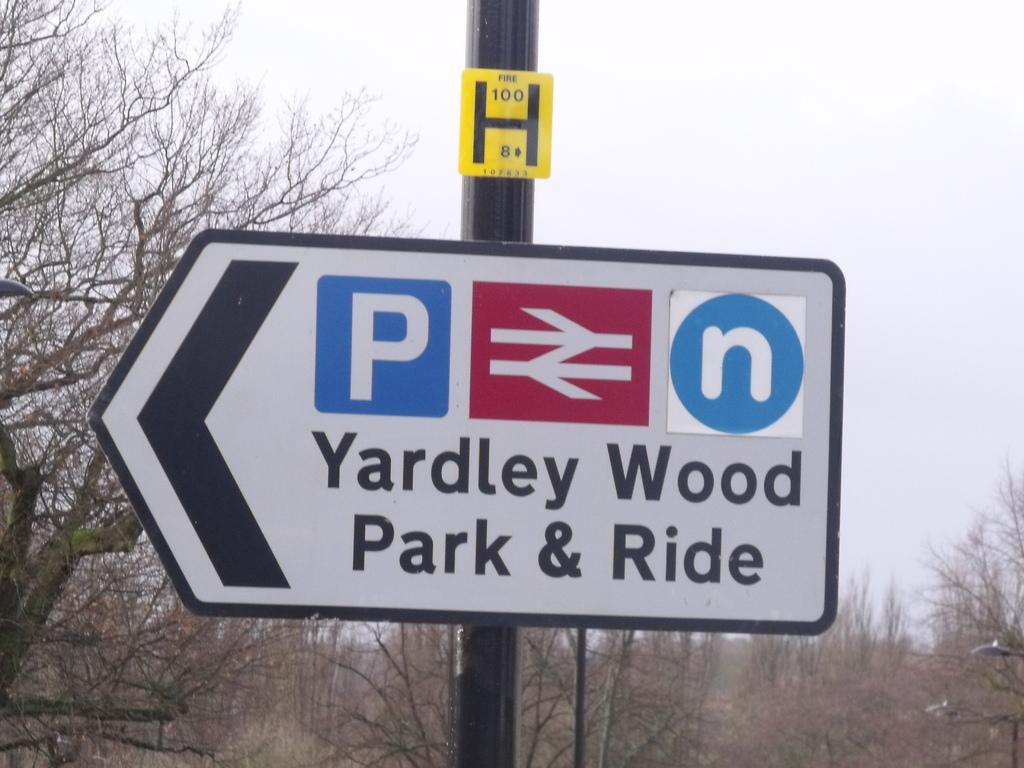Where is the park & ride?
Keep it short and to the point. Yardley wood. What number is on the yellow sign?
Your answer should be compact. 100. 